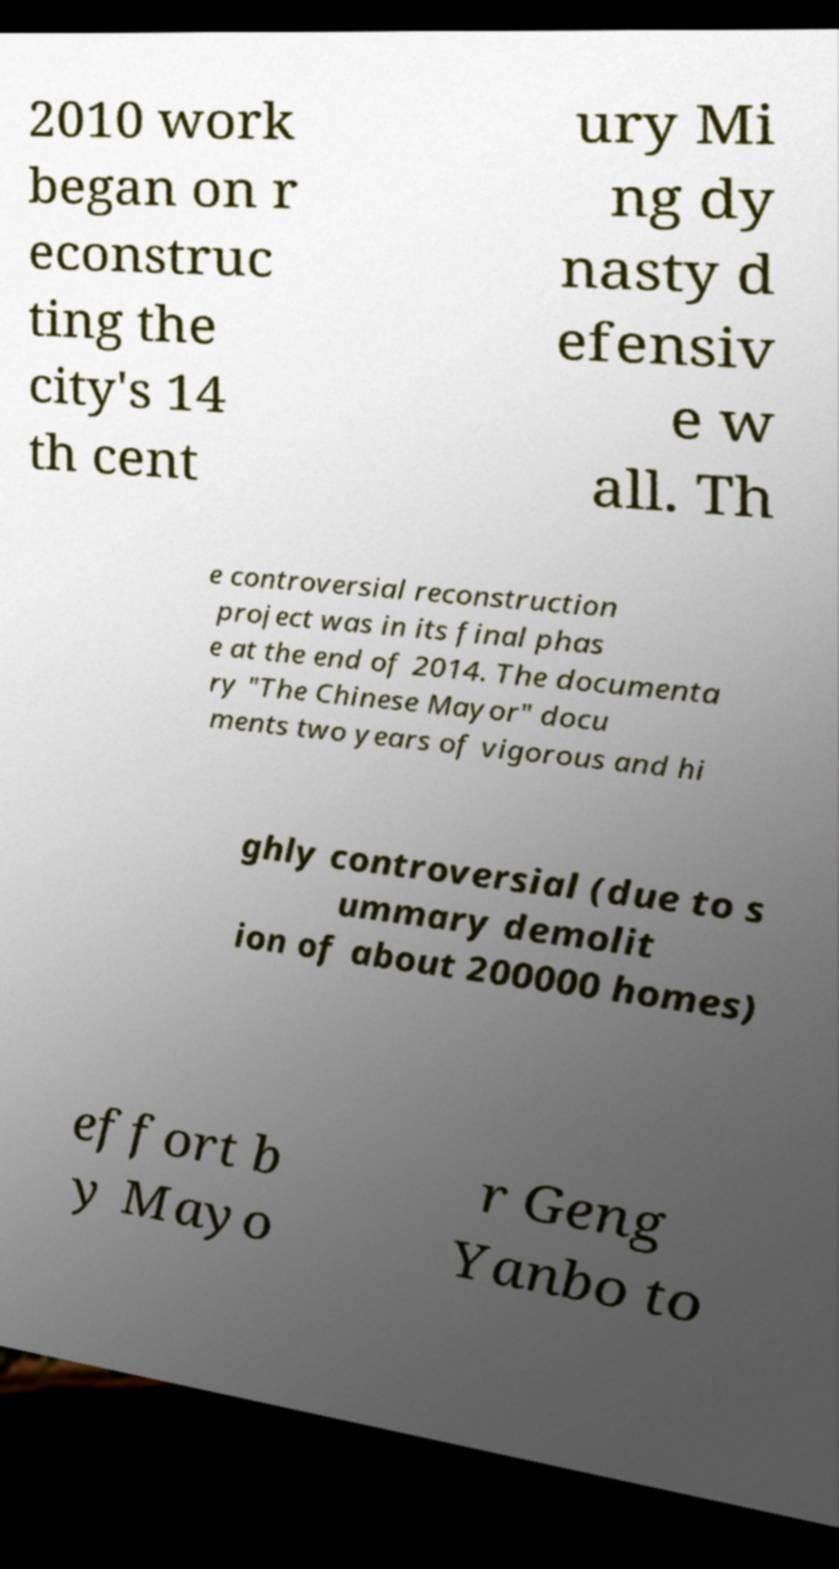Could you assist in decoding the text presented in this image and type it out clearly? 2010 work began on r econstruc ting the city's 14 th cent ury Mi ng dy nasty d efensiv e w all. Th e controversial reconstruction project was in its final phas e at the end of 2014. The documenta ry "The Chinese Mayor" docu ments two years of vigorous and hi ghly controversial (due to s ummary demolit ion of about 200000 homes) effort b y Mayo r Geng Yanbo to 